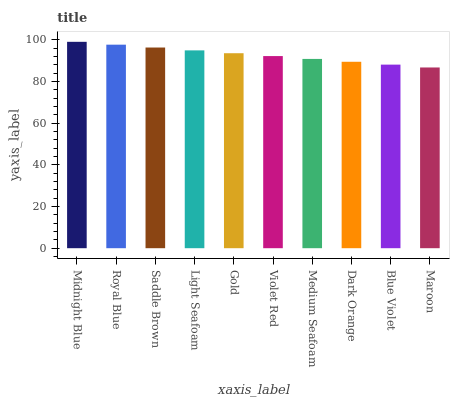Is Maroon the minimum?
Answer yes or no. Yes. Is Midnight Blue the maximum?
Answer yes or no. Yes. Is Royal Blue the minimum?
Answer yes or no. No. Is Royal Blue the maximum?
Answer yes or no. No. Is Midnight Blue greater than Royal Blue?
Answer yes or no. Yes. Is Royal Blue less than Midnight Blue?
Answer yes or no. Yes. Is Royal Blue greater than Midnight Blue?
Answer yes or no. No. Is Midnight Blue less than Royal Blue?
Answer yes or no. No. Is Gold the high median?
Answer yes or no. Yes. Is Violet Red the low median?
Answer yes or no. Yes. Is Medium Seafoam the high median?
Answer yes or no. No. Is Midnight Blue the low median?
Answer yes or no. No. 